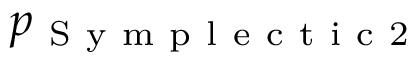<formula> <loc_0><loc_0><loc_500><loc_500>p _ { S y m p l e c t i c 2 }</formula> 